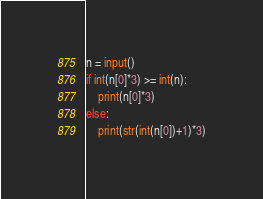<code> <loc_0><loc_0><loc_500><loc_500><_Python_>n = input()
if int(n[0]*3) >= int(n):
    print(n[0]*3)
else:
    print(str(int(n[0])+1)*3)</code> 